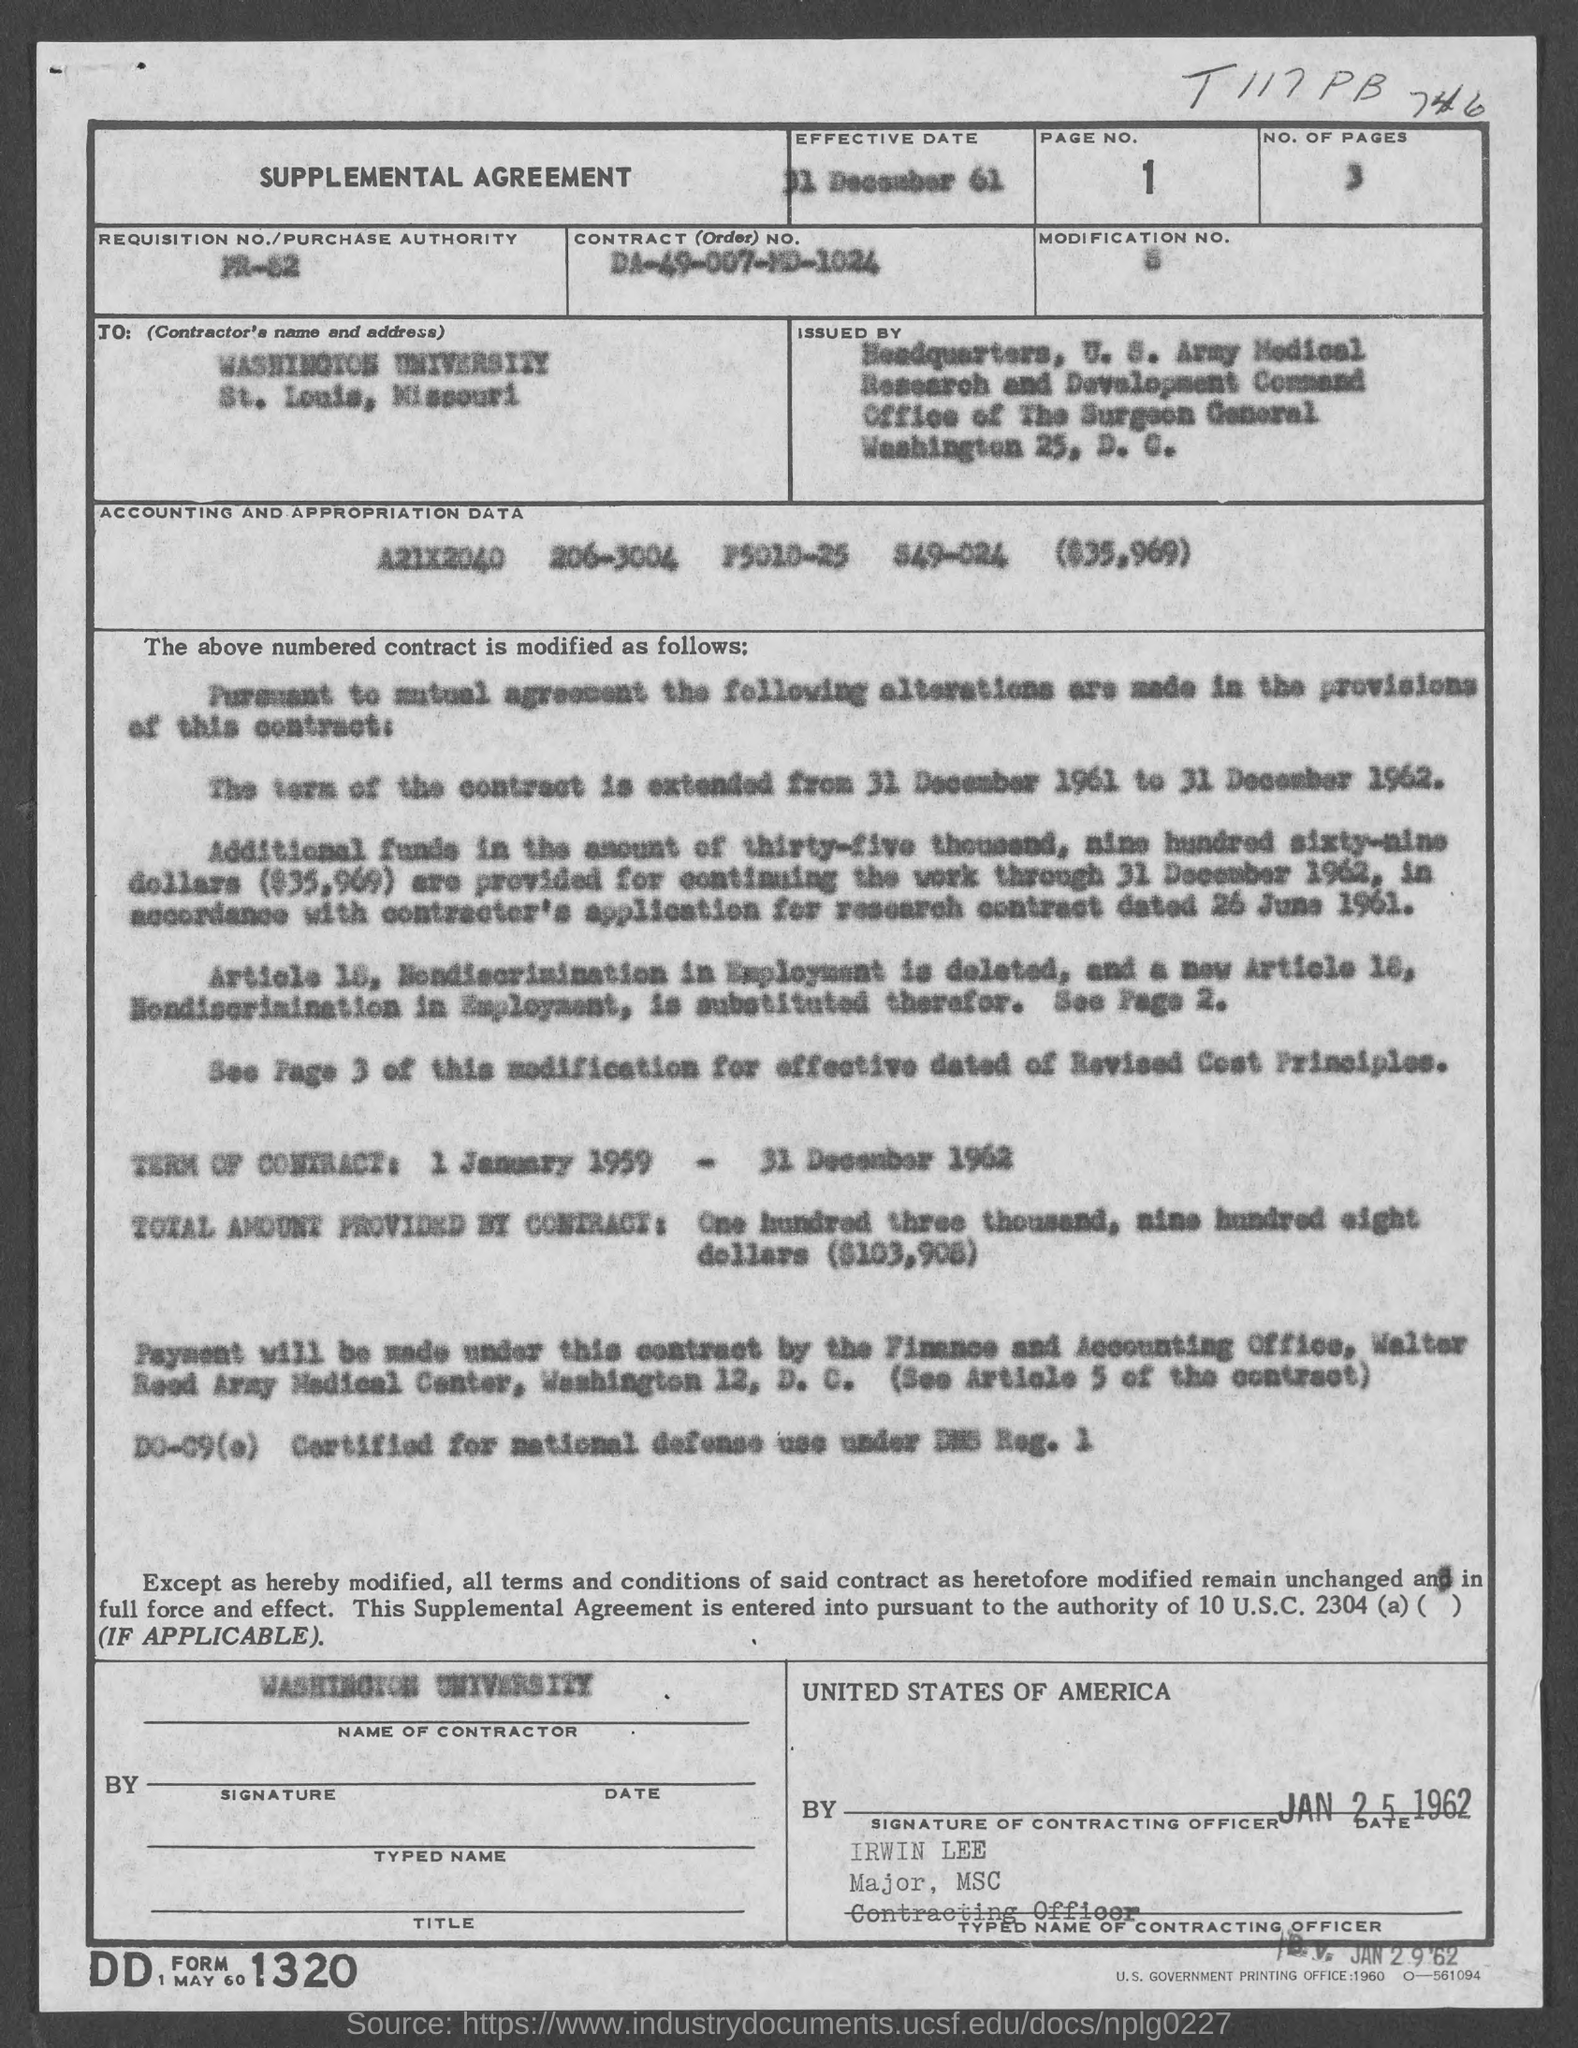What is the page no.?
Your answer should be very brief. 1. What is the no. of pages ?
Give a very brief answer. 3. What is the effective date?
Give a very brief answer. 31 december 61. What is the  contract no.?
Your answer should be compact. DA-49-007-MD-1024. 